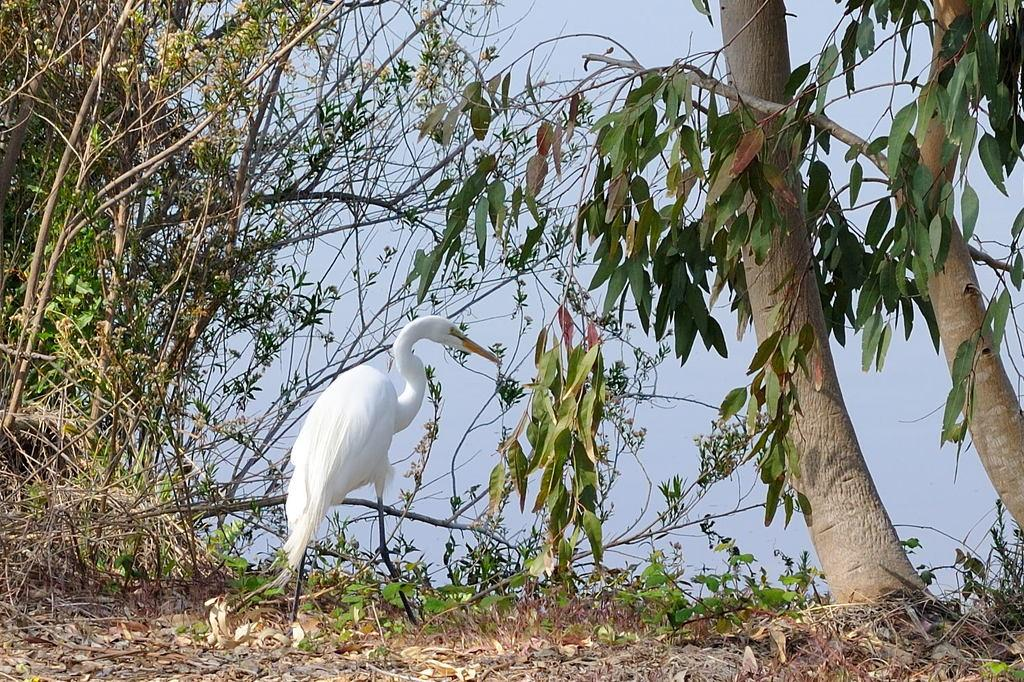What type of bird is in the image? There is a white-colored water bird in the image. Where is the bird located in the image? The bird is standing on the ground. What can be seen beside the bird? There are trees beside the bird. What is visible at the top of the image? The sky is visible at the top of the image. What is present on the ground near the bird? There are dry leaves on the ground. What type of jail can be seen in the image? There is no jail present in the image; it features a white-colored water bird standing on the ground with trees and dry leaves nearby. How does the frame of the image affect the acoustics of the scene? The image is a still photograph and does not have acoustics, so the frame does not affect any sound in the scene. 